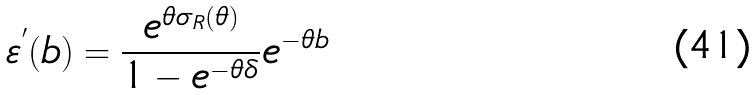Convert formula to latex. <formula><loc_0><loc_0><loc_500><loc_500>\varepsilon ^ { ^ { \prime } } ( b ) = \frac { e ^ { \theta \sigma _ { R } ( \theta ) } } { 1 - e ^ { - \theta \delta } } e ^ { - \theta b }</formula> 